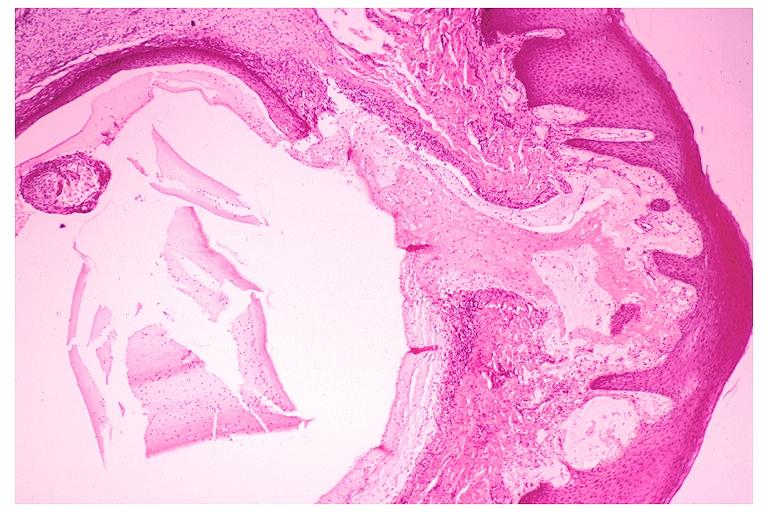does this image show mucocele?
Answer the question using a single word or phrase. Yes 